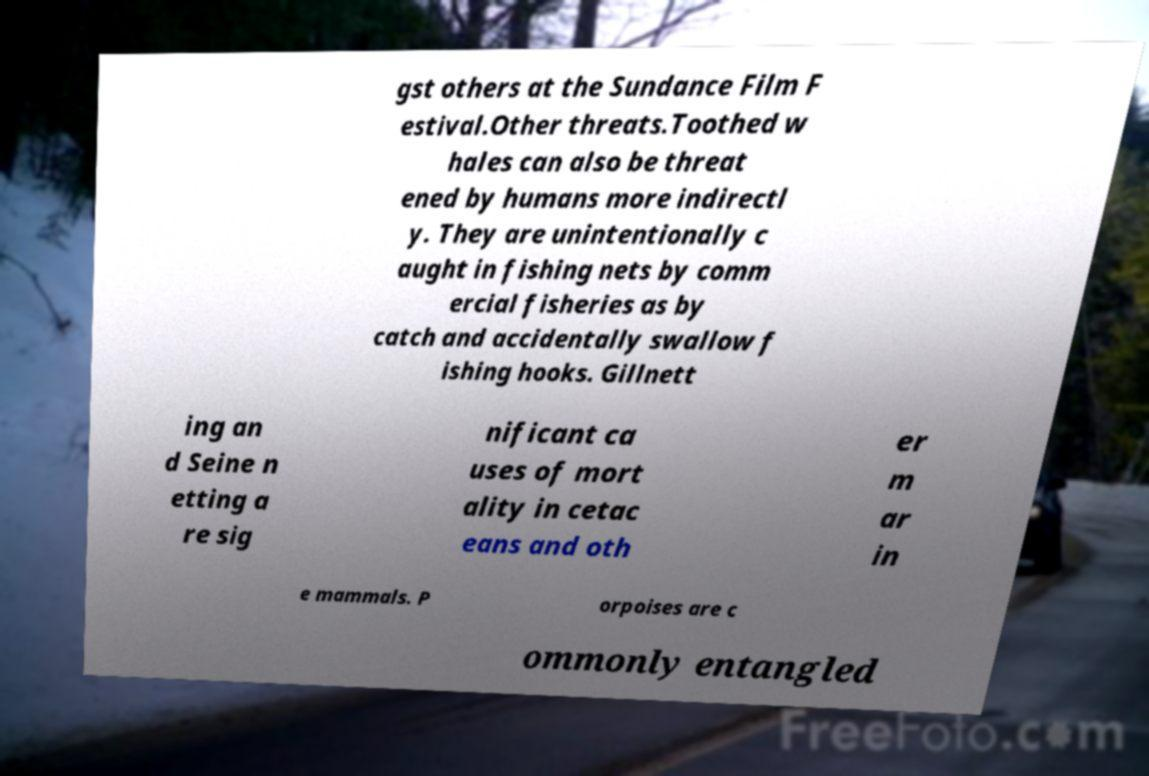What messages or text are displayed in this image? I need them in a readable, typed format. gst others at the Sundance Film F estival.Other threats.Toothed w hales can also be threat ened by humans more indirectl y. They are unintentionally c aught in fishing nets by comm ercial fisheries as by catch and accidentally swallow f ishing hooks. Gillnett ing an d Seine n etting a re sig nificant ca uses of mort ality in cetac eans and oth er m ar in e mammals. P orpoises are c ommonly entangled 